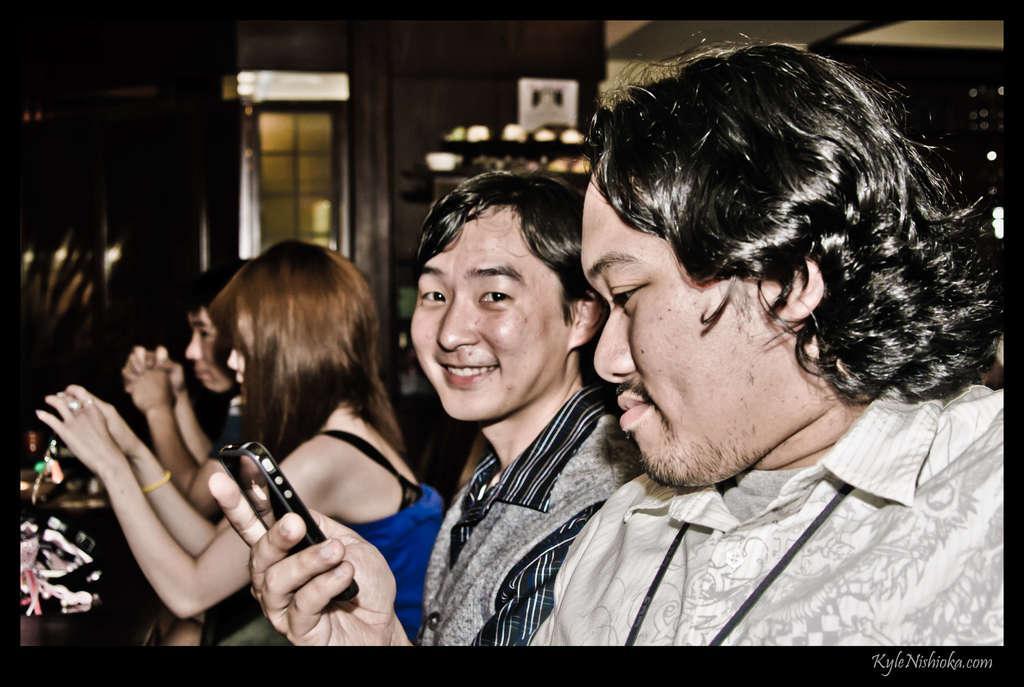Could you give a brief overview of what you see in this image? In this picture I can see few people are sitting and holding mobiles in hands. 